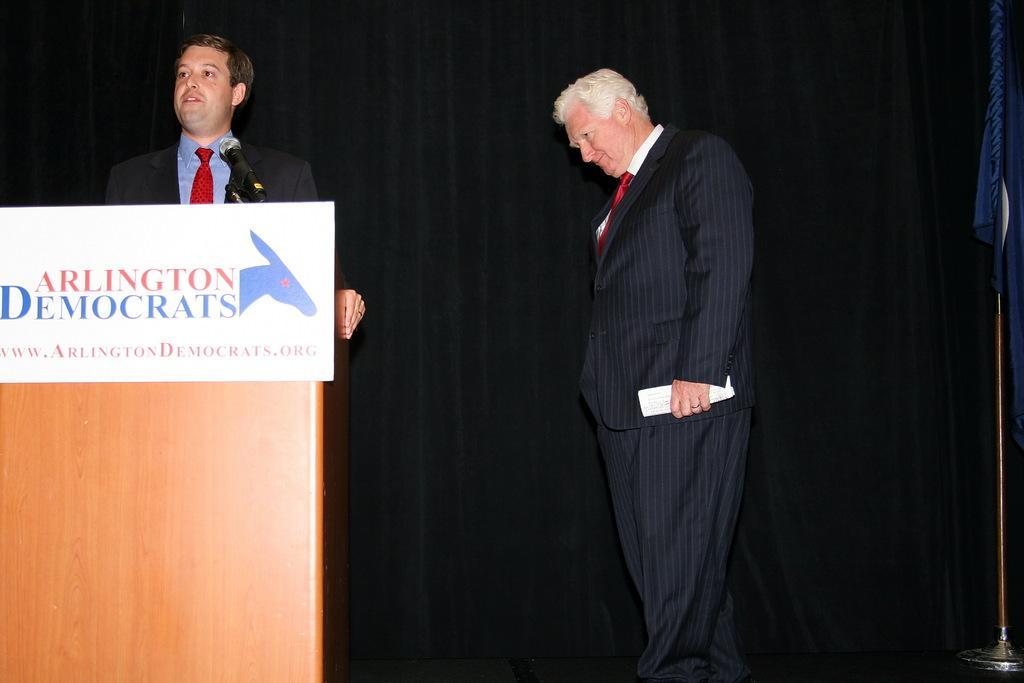How would you summarize this image in a sentence or two? In the image there is a man standing in front of a table and there is some text on a sheet attached to the table. Beside him there is another man and in the background there is a curtain. 